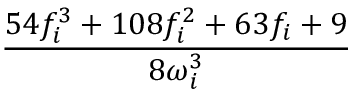<formula> <loc_0><loc_0><loc_500><loc_500>\frac { 5 4 f _ { i } ^ { 3 } + 1 0 8 f _ { i } ^ { 2 } + 6 3 f _ { i } + 9 } { 8 \omega _ { i } ^ { 3 } }</formula> 